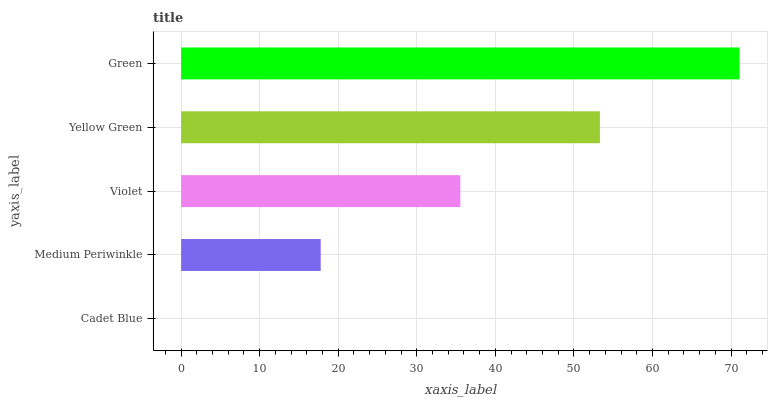Is Cadet Blue the minimum?
Answer yes or no. Yes. Is Green the maximum?
Answer yes or no. Yes. Is Medium Periwinkle the minimum?
Answer yes or no. No. Is Medium Periwinkle the maximum?
Answer yes or no. No. Is Medium Periwinkle greater than Cadet Blue?
Answer yes or no. Yes. Is Cadet Blue less than Medium Periwinkle?
Answer yes or no. Yes. Is Cadet Blue greater than Medium Periwinkle?
Answer yes or no. No. Is Medium Periwinkle less than Cadet Blue?
Answer yes or no. No. Is Violet the high median?
Answer yes or no. Yes. Is Violet the low median?
Answer yes or no. Yes. Is Green the high median?
Answer yes or no. No. Is Cadet Blue the low median?
Answer yes or no. No. 